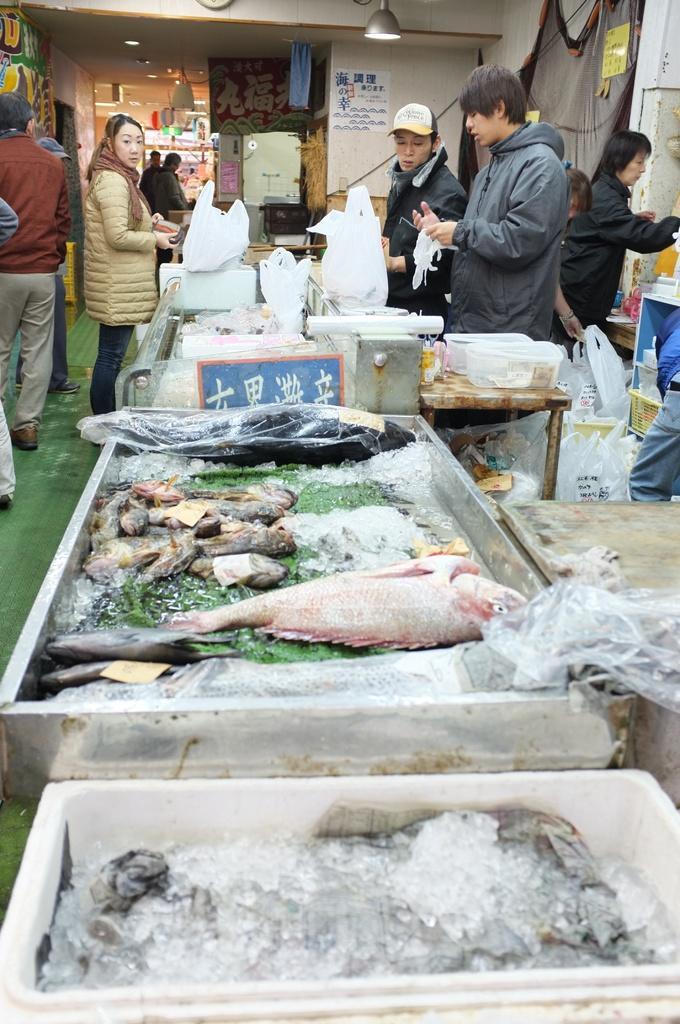In one or two sentences, can you explain what this image depicts? In this picture there are people and we can see fish, ice, cloth and covers in containers. We can see covers, boxes and objects on tables. We can see covers and floor. In the background of the image we can see posters, wall, cloth, lights and objects. 